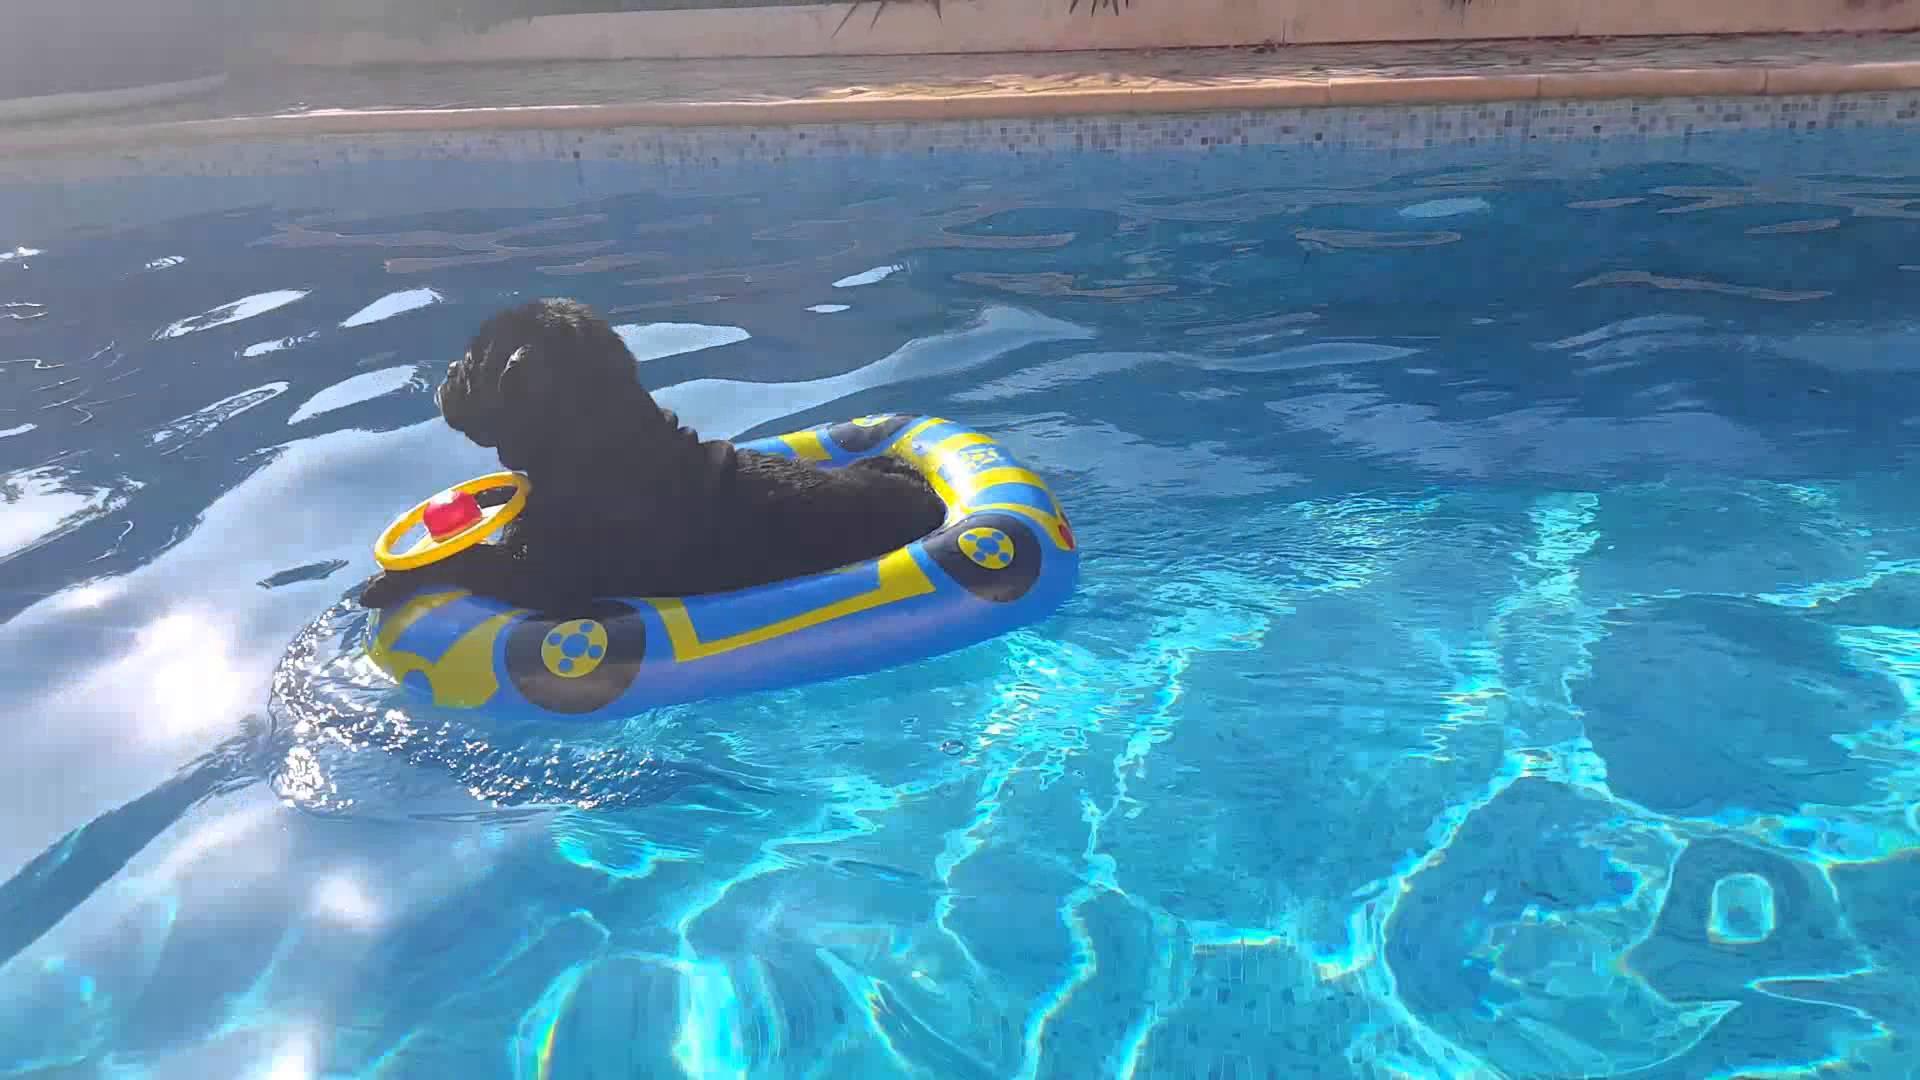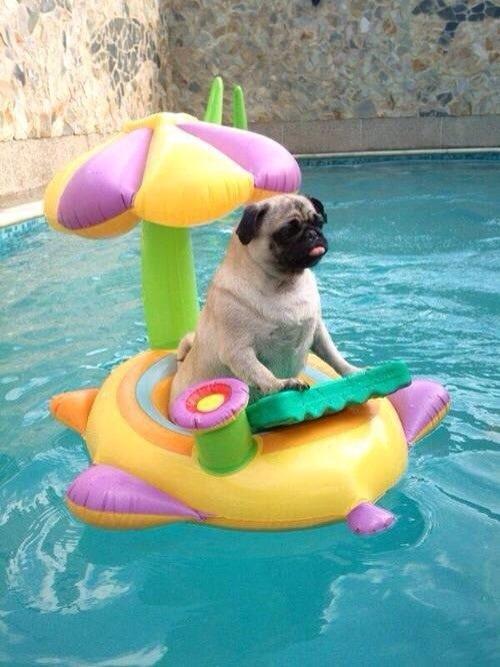The first image is the image on the left, the second image is the image on the right. Considering the images on both sides, is "Only one pug is wearing a life vest." valid? Answer yes or no. No. The first image is the image on the left, the second image is the image on the right. For the images shown, is this caption "The pug in the left image is wearing a swimming vest." true? Answer yes or no. No. 